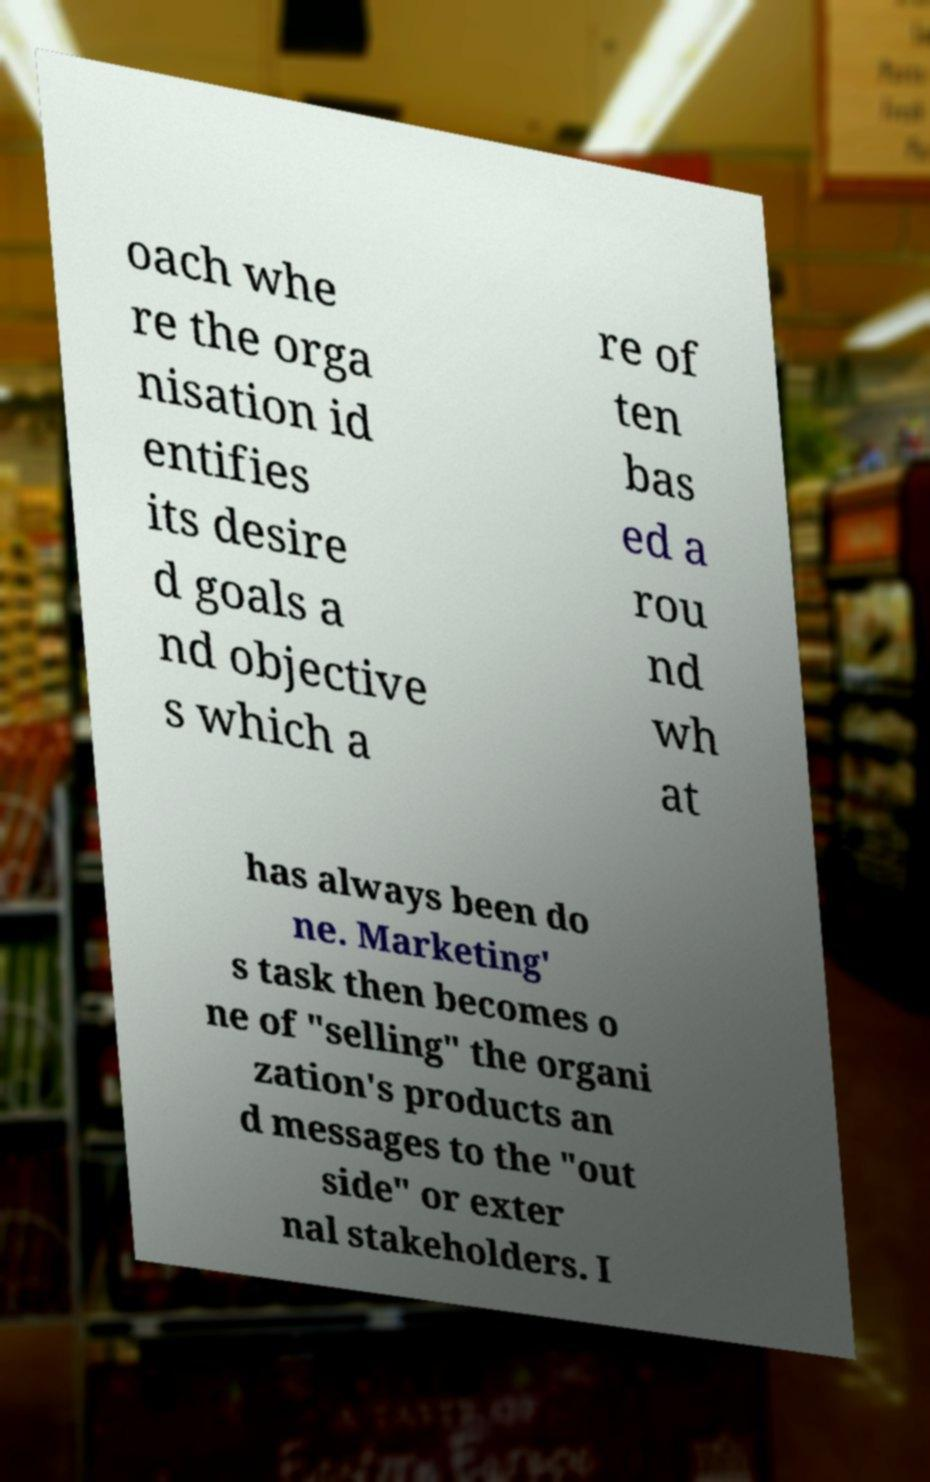Please identify and transcribe the text found in this image. oach whe re the orga nisation id entifies its desire d goals a nd objective s which a re of ten bas ed a rou nd wh at has always been do ne. Marketing' s task then becomes o ne of "selling" the organi zation's products an d messages to the "out side" or exter nal stakeholders. I 